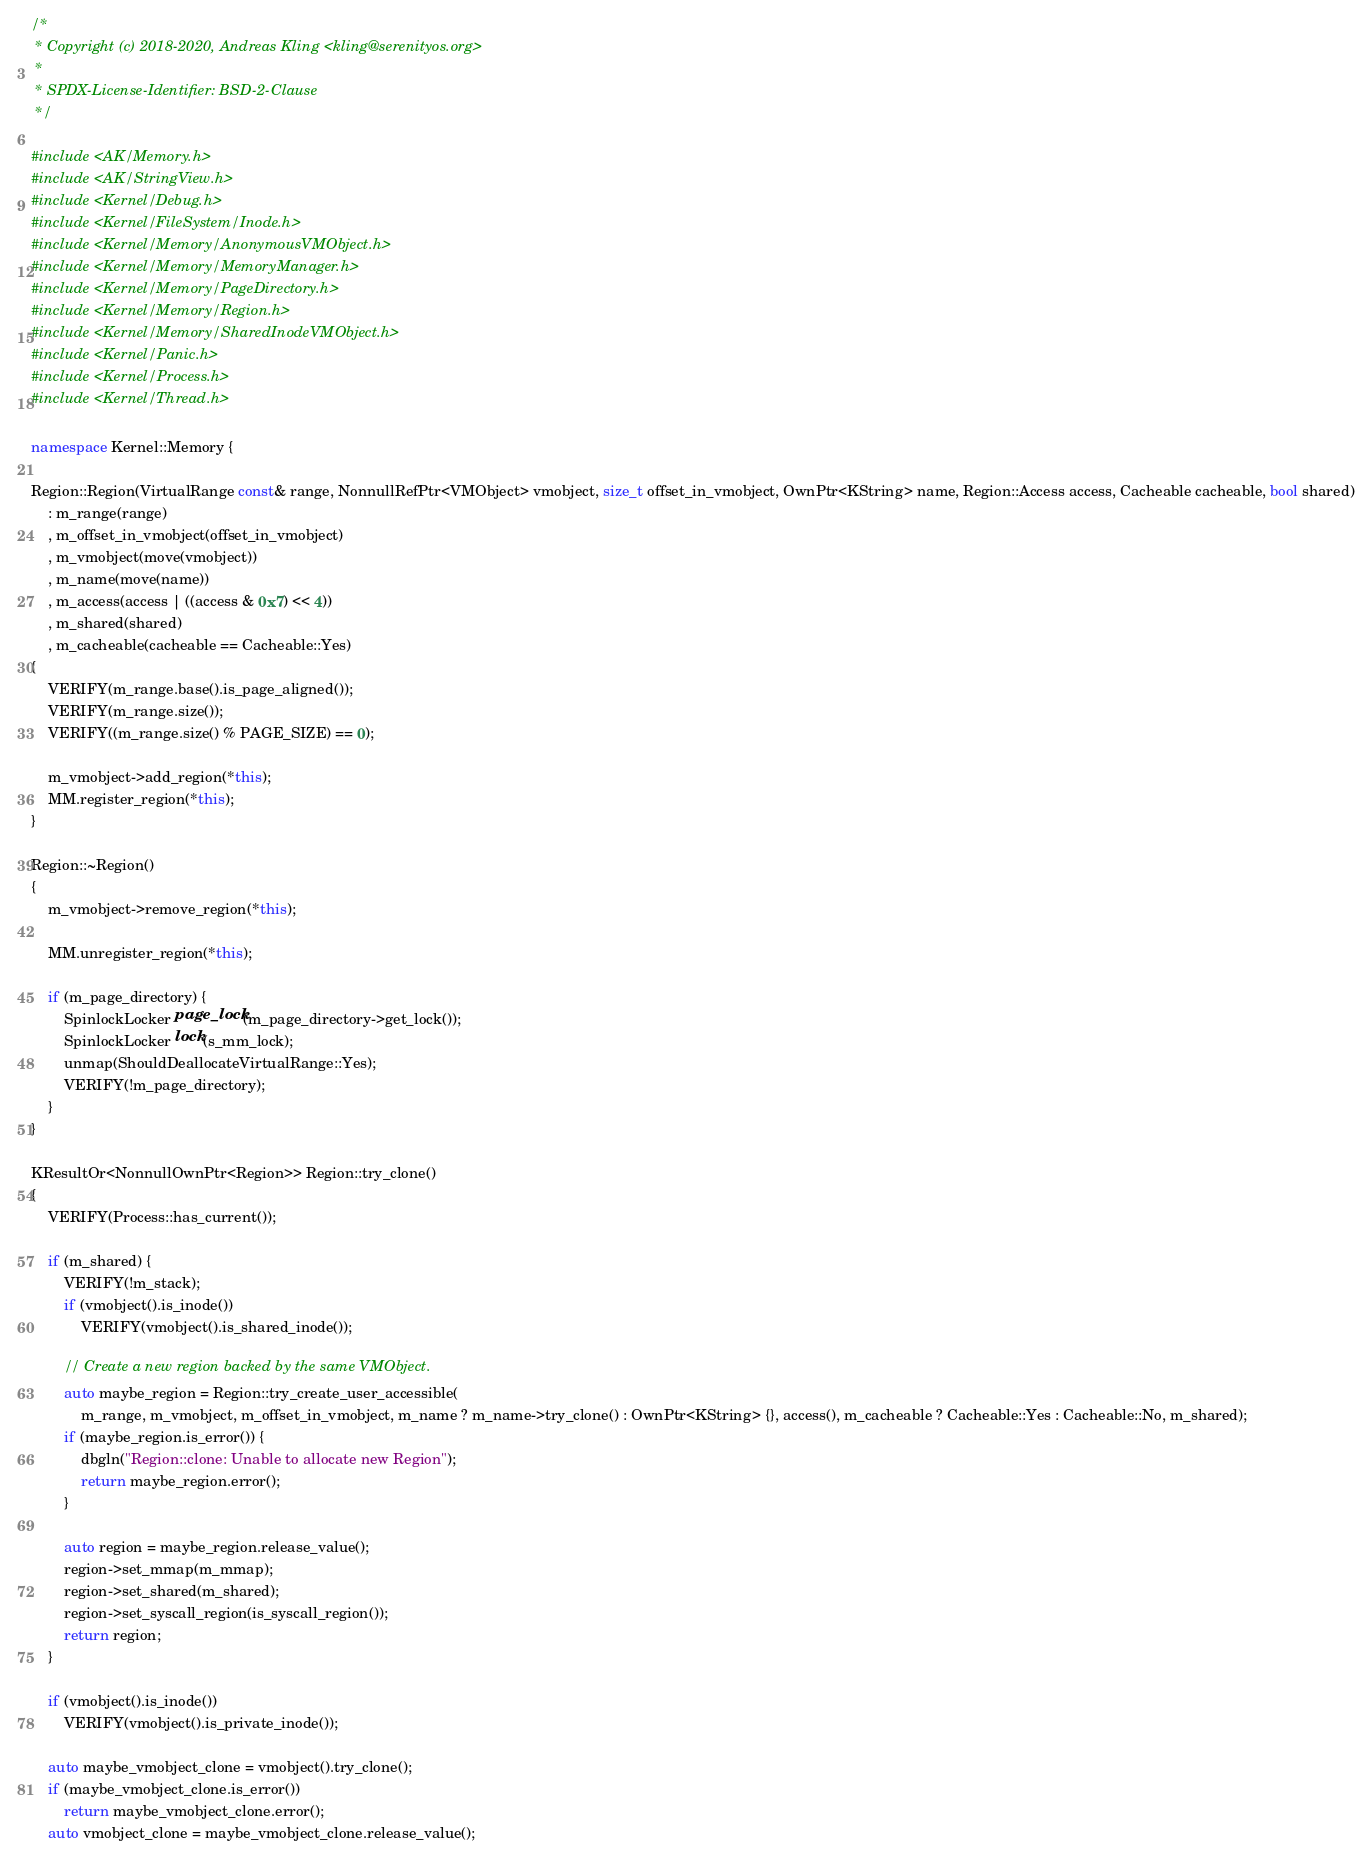<code> <loc_0><loc_0><loc_500><loc_500><_C++_>/*
 * Copyright (c) 2018-2020, Andreas Kling <kling@serenityos.org>
 *
 * SPDX-License-Identifier: BSD-2-Clause
 */

#include <AK/Memory.h>
#include <AK/StringView.h>
#include <Kernel/Debug.h>
#include <Kernel/FileSystem/Inode.h>
#include <Kernel/Memory/AnonymousVMObject.h>
#include <Kernel/Memory/MemoryManager.h>
#include <Kernel/Memory/PageDirectory.h>
#include <Kernel/Memory/Region.h>
#include <Kernel/Memory/SharedInodeVMObject.h>
#include <Kernel/Panic.h>
#include <Kernel/Process.h>
#include <Kernel/Thread.h>

namespace Kernel::Memory {

Region::Region(VirtualRange const& range, NonnullRefPtr<VMObject> vmobject, size_t offset_in_vmobject, OwnPtr<KString> name, Region::Access access, Cacheable cacheable, bool shared)
    : m_range(range)
    , m_offset_in_vmobject(offset_in_vmobject)
    , m_vmobject(move(vmobject))
    , m_name(move(name))
    , m_access(access | ((access & 0x7) << 4))
    , m_shared(shared)
    , m_cacheable(cacheable == Cacheable::Yes)
{
    VERIFY(m_range.base().is_page_aligned());
    VERIFY(m_range.size());
    VERIFY((m_range.size() % PAGE_SIZE) == 0);

    m_vmobject->add_region(*this);
    MM.register_region(*this);
}

Region::~Region()
{
    m_vmobject->remove_region(*this);

    MM.unregister_region(*this);

    if (m_page_directory) {
        SpinlockLocker page_lock(m_page_directory->get_lock());
        SpinlockLocker lock(s_mm_lock);
        unmap(ShouldDeallocateVirtualRange::Yes);
        VERIFY(!m_page_directory);
    }
}

KResultOr<NonnullOwnPtr<Region>> Region::try_clone()
{
    VERIFY(Process::has_current());

    if (m_shared) {
        VERIFY(!m_stack);
        if (vmobject().is_inode())
            VERIFY(vmobject().is_shared_inode());

        // Create a new region backed by the same VMObject.
        auto maybe_region = Region::try_create_user_accessible(
            m_range, m_vmobject, m_offset_in_vmobject, m_name ? m_name->try_clone() : OwnPtr<KString> {}, access(), m_cacheable ? Cacheable::Yes : Cacheable::No, m_shared);
        if (maybe_region.is_error()) {
            dbgln("Region::clone: Unable to allocate new Region");
            return maybe_region.error();
        }

        auto region = maybe_region.release_value();
        region->set_mmap(m_mmap);
        region->set_shared(m_shared);
        region->set_syscall_region(is_syscall_region());
        return region;
    }

    if (vmobject().is_inode())
        VERIFY(vmobject().is_private_inode());

    auto maybe_vmobject_clone = vmobject().try_clone();
    if (maybe_vmobject_clone.is_error())
        return maybe_vmobject_clone.error();
    auto vmobject_clone = maybe_vmobject_clone.release_value();
</code> 